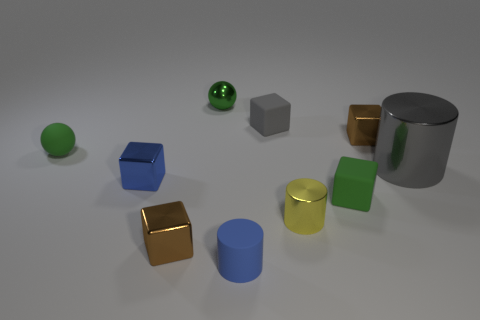How many brown balls are there?
Offer a very short reply. 0. What number of cyan objects are either small metal things or blocks?
Make the answer very short. 0. What number of other objects are the same shape as the yellow metallic thing?
Give a very brief answer. 2. There is a tiny matte ball left of the small blue cube; is its color the same as the tiny metal cube that is behind the big metallic object?
Provide a short and direct response. No. How many tiny objects are either blue cylinders or gray rubber things?
Give a very brief answer. 2. What size is the other rubber thing that is the same shape as the small gray object?
Provide a short and direct response. Small. Is there anything else that is the same size as the gray shiny thing?
Keep it short and to the point. No. What is the green object left of the small blue thing that is behind the tiny yellow shiny cylinder made of?
Your answer should be very brief. Rubber. What number of matte things are tiny blue spheres or yellow cylinders?
Offer a terse response. 0. What is the color of the matte object that is the same shape as the large metal thing?
Your response must be concise. Blue. 